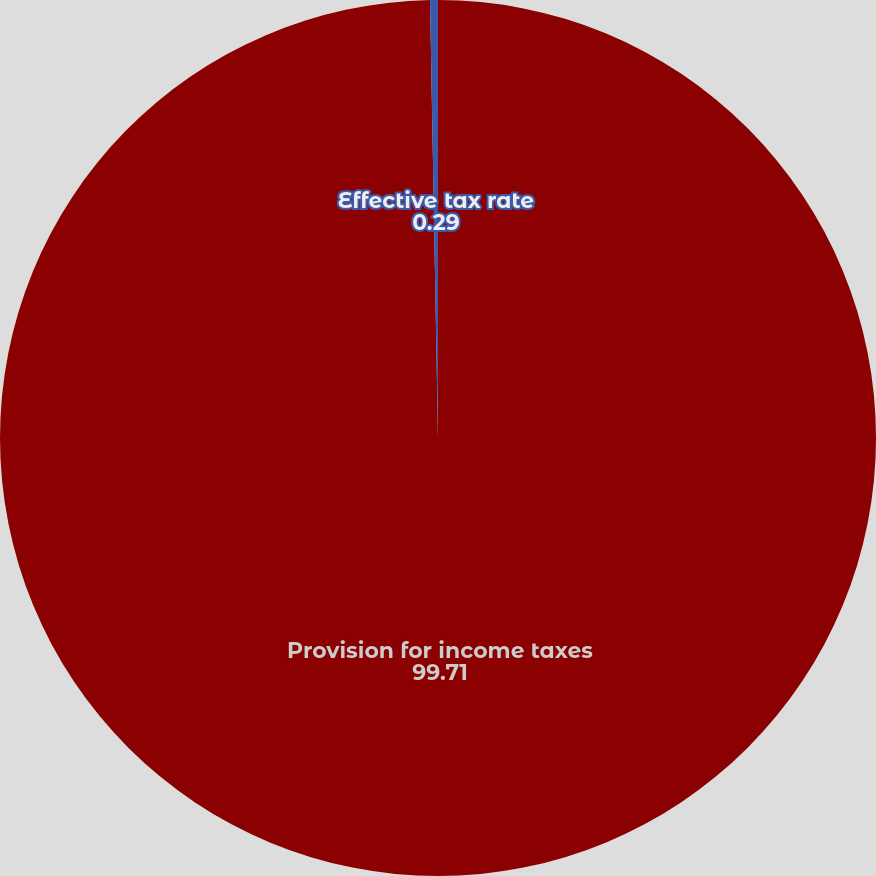Convert chart. <chart><loc_0><loc_0><loc_500><loc_500><pie_chart><fcel>Provision for income taxes<fcel>Effective tax rate<nl><fcel>99.71%<fcel>0.29%<nl></chart> 